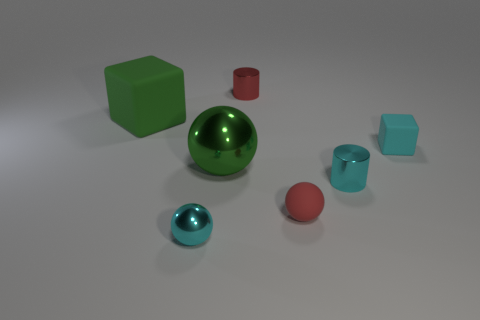How many of each shape are present in this composition? Analyzing the image, I can identify the following: There are two cubes, one large green and one smaller cyan; two spheres, one large metallic green and one smaller red; and one cylinder in red color. 